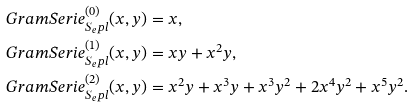Convert formula to latex. <formula><loc_0><loc_0><loc_500><loc_500>\ G r a m S e r i e _ { S _ { e } p l } ^ { ( 0 ) } ( x , y ) & = x , \\ \ G r a m S e r i e _ { S _ { e } p l } ^ { ( 1 ) } ( x , y ) & = x y + x ^ { 2 } y , \\ \ G r a m S e r i e _ { S _ { e } p l } ^ { ( 2 ) } ( x , y ) & = x ^ { 2 } y + x ^ { 3 } y + x ^ { 3 } y ^ { 2 } + 2 x ^ { 4 } y ^ { 2 } + x ^ { 5 } y ^ { 2 } .</formula> 